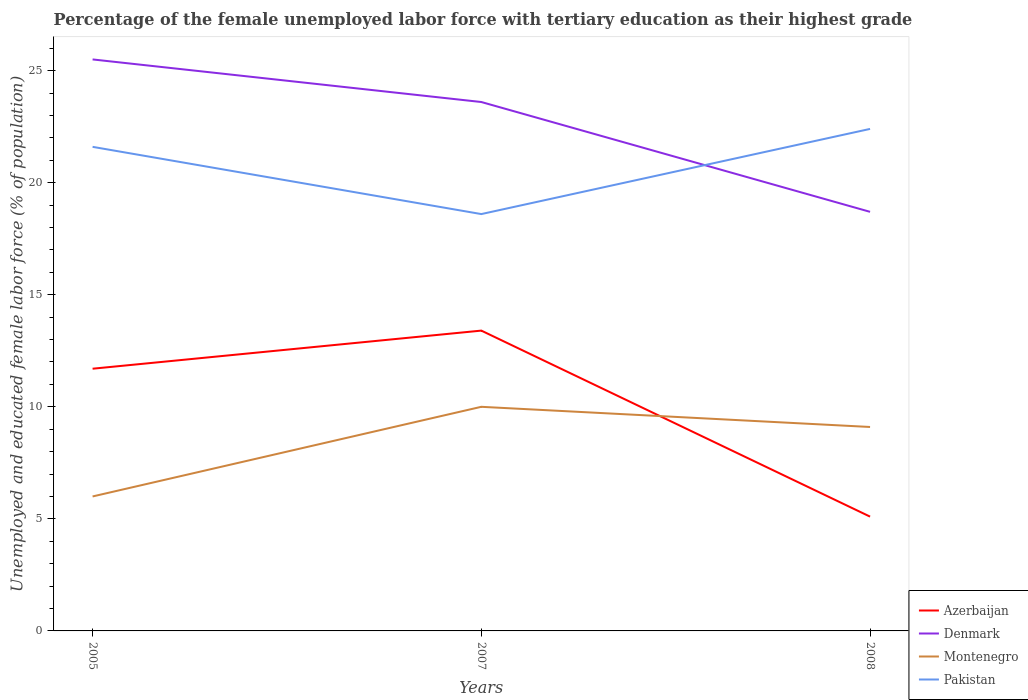How many different coloured lines are there?
Provide a succinct answer. 4. Is the number of lines equal to the number of legend labels?
Make the answer very short. Yes. Across all years, what is the maximum percentage of the unemployed female labor force with tertiary education in Denmark?
Provide a short and direct response. 18.7. In which year was the percentage of the unemployed female labor force with tertiary education in Azerbaijan maximum?
Keep it short and to the point. 2008. What is the total percentage of the unemployed female labor force with tertiary education in Pakistan in the graph?
Your answer should be compact. 3. What is the difference between the highest and the second highest percentage of the unemployed female labor force with tertiary education in Denmark?
Provide a short and direct response. 6.8. How many years are there in the graph?
Keep it short and to the point. 3. Where does the legend appear in the graph?
Keep it short and to the point. Bottom right. How are the legend labels stacked?
Your answer should be compact. Vertical. What is the title of the graph?
Ensure brevity in your answer.  Percentage of the female unemployed labor force with tertiary education as their highest grade. Does "High income: OECD" appear as one of the legend labels in the graph?
Your response must be concise. No. What is the label or title of the Y-axis?
Offer a very short reply. Unemployed and educated female labor force (% of population). What is the Unemployed and educated female labor force (% of population) of Azerbaijan in 2005?
Your answer should be very brief. 11.7. What is the Unemployed and educated female labor force (% of population) in Pakistan in 2005?
Keep it short and to the point. 21.6. What is the Unemployed and educated female labor force (% of population) of Azerbaijan in 2007?
Your answer should be compact. 13.4. What is the Unemployed and educated female labor force (% of population) in Denmark in 2007?
Keep it short and to the point. 23.6. What is the Unemployed and educated female labor force (% of population) in Pakistan in 2007?
Your answer should be compact. 18.6. What is the Unemployed and educated female labor force (% of population) of Azerbaijan in 2008?
Your response must be concise. 5.1. What is the Unemployed and educated female labor force (% of population) in Denmark in 2008?
Your response must be concise. 18.7. What is the Unemployed and educated female labor force (% of population) of Montenegro in 2008?
Keep it short and to the point. 9.1. What is the Unemployed and educated female labor force (% of population) in Pakistan in 2008?
Give a very brief answer. 22.4. Across all years, what is the maximum Unemployed and educated female labor force (% of population) in Azerbaijan?
Make the answer very short. 13.4. Across all years, what is the maximum Unemployed and educated female labor force (% of population) in Denmark?
Ensure brevity in your answer.  25.5. Across all years, what is the maximum Unemployed and educated female labor force (% of population) of Montenegro?
Provide a short and direct response. 10. Across all years, what is the maximum Unemployed and educated female labor force (% of population) of Pakistan?
Ensure brevity in your answer.  22.4. Across all years, what is the minimum Unemployed and educated female labor force (% of population) in Azerbaijan?
Your answer should be very brief. 5.1. Across all years, what is the minimum Unemployed and educated female labor force (% of population) in Denmark?
Give a very brief answer. 18.7. Across all years, what is the minimum Unemployed and educated female labor force (% of population) in Montenegro?
Make the answer very short. 6. Across all years, what is the minimum Unemployed and educated female labor force (% of population) in Pakistan?
Provide a succinct answer. 18.6. What is the total Unemployed and educated female labor force (% of population) in Azerbaijan in the graph?
Make the answer very short. 30.2. What is the total Unemployed and educated female labor force (% of population) in Denmark in the graph?
Make the answer very short. 67.8. What is the total Unemployed and educated female labor force (% of population) in Montenegro in the graph?
Provide a short and direct response. 25.1. What is the total Unemployed and educated female labor force (% of population) of Pakistan in the graph?
Your answer should be very brief. 62.6. What is the difference between the Unemployed and educated female labor force (% of population) of Azerbaijan in 2005 and that in 2007?
Your response must be concise. -1.7. What is the difference between the Unemployed and educated female labor force (% of population) of Denmark in 2005 and that in 2007?
Provide a short and direct response. 1.9. What is the difference between the Unemployed and educated female labor force (% of population) in Pakistan in 2005 and that in 2008?
Your response must be concise. -0.8. What is the difference between the Unemployed and educated female labor force (% of population) in Azerbaijan in 2007 and that in 2008?
Offer a very short reply. 8.3. What is the difference between the Unemployed and educated female labor force (% of population) of Denmark in 2007 and that in 2008?
Make the answer very short. 4.9. What is the difference between the Unemployed and educated female labor force (% of population) of Pakistan in 2007 and that in 2008?
Your answer should be compact. -3.8. What is the difference between the Unemployed and educated female labor force (% of population) in Azerbaijan in 2005 and the Unemployed and educated female labor force (% of population) in Pakistan in 2007?
Make the answer very short. -6.9. What is the difference between the Unemployed and educated female labor force (% of population) of Montenegro in 2005 and the Unemployed and educated female labor force (% of population) of Pakistan in 2007?
Your response must be concise. -12.6. What is the difference between the Unemployed and educated female labor force (% of population) of Azerbaijan in 2005 and the Unemployed and educated female labor force (% of population) of Denmark in 2008?
Ensure brevity in your answer.  -7. What is the difference between the Unemployed and educated female labor force (% of population) in Denmark in 2005 and the Unemployed and educated female labor force (% of population) in Montenegro in 2008?
Your response must be concise. 16.4. What is the difference between the Unemployed and educated female labor force (% of population) of Montenegro in 2005 and the Unemployed and educated female labor force (% of population) of Pakistan in 2008?
Give a very brief answer. -16.4. What is the average Unemployed and educated female labor force (% of population) of Azerbaijan per year?
Offer a terse response. 10.07. What is the average Unemployed and educated female labor force (% of population) of Denmark per year?
Offer a terse response. 22.6. What is the average Unemployed and educated female labor force (% of population) of Montenegro per year?
Give a very brief answer. 8.37. What is the average Unemployed and educated female labor force (% of population) of Pakistan per year?
Keep it short and to the point. 20.87. In the year 2005, what is the difference between the Unemployed and educated female labor force (% of population) of Azerbaijan and Unemployed and educated female labor force (% of population) of Montenegro?
Provide a short and direct response. 5.7. In the year 2005, what is the difference between the Unemployed and educated female labor force (% of population) of Azerbaijan and Unemployed and educated female labor force (% of population) of Pakistan?
Your answer should be very brief. -9.9. In the year 2005, what is the difference between the Unemployed and educated female labor force (% of population) of Montenegro and Unemployed and educated female labor force (% of population) of Pakistan?
Your response must be concise. -15.6. In the year 2008, what is the difference between the Unemployed and educated female labor force (% of population) in Azerbaijan and Unemployed and educated female labor force (% of population) in Montenegro?
Make the answer very short. -4. In the year 2008, what is the difference between the Unemployed and educated female labor force (% of population) of Azerbaijan and Unemployed and educated female labor force (% of population) of Pakistan?
Give a very brief answer. -17.3. What is the ratio of the Unemployed and educated female labor force (% of population) in Azerbaijan in 2005 to that in 2007?
Provide a succinct answer. 0.87. What is the ratio of the Unemployed and educated female labor force (% of population) of Denmark in 2005 to that in 2007?
Provide a succinct answer. 1.08. What is the ratio of the Unemployed and educated female labor force (% of population) of Pakistan in 2005 to that in 2007?
Your response must be concise. 1.16. What is the ratio of the Unemployed and educated female labor force (% of population) of Azerbaijan in 2005 to that in 2008?
Your answer should be very brief. 2.29. What is the ratio of the Unemployed and educated female labor force (% of population) in Denmark in 2005 to that in 2008?
Give a very brief answer. 1.36. What is the ratio of the Unemployed and educated female labor force (% of population) of Montenegro in 2005 to that in 2008?
Your response must be concise. 0.66. What is the ratio of the Unemployed and educated female labor force (% of population) in Azerbaijan in 2007 to that in 2008?
Keep it short and to the point. 2.63. What is the ratio of the Unemployed and educated female labor force (% of population) of Denmark in 2007 to that in 2008?
Make the answer very short. 1.26. What is the ratio of the Unemployed and educated female labor force (% of population) of Montenegro in 2007 to that in 2008?
Ensure brevity in your answer.  1.1. What is the ratio of the Unemployed and educated female labor force (% of population) in Pakistan in 2007 to that in 2008?
Your answer should be compact. 0.83. What is the difference between the highest and the second highest Unemployed and educated female labor force (% of population) of Denmark?
Your answer should be very brief. 1.9. What is the difference between the highest and the second highest Unemployed and educated female labor force (% of population) in Montenegro?
Make the answer very short. 0.9. What is the difference between the highest and the lowest Unemployed and educated female labor force (% of population) in Azerbaijan?
Provide a short and direct response. 8.3. What is the difference between the highest and the lowest Unemployed and educated female labor force (% of population) in Denmark?
Give a very brief answer. 6.8. What is the difference between the highest and the lowest Unemployed and educated female labor force (% of population) of Pakistan?
Keep it short and to the point. 3.8. 